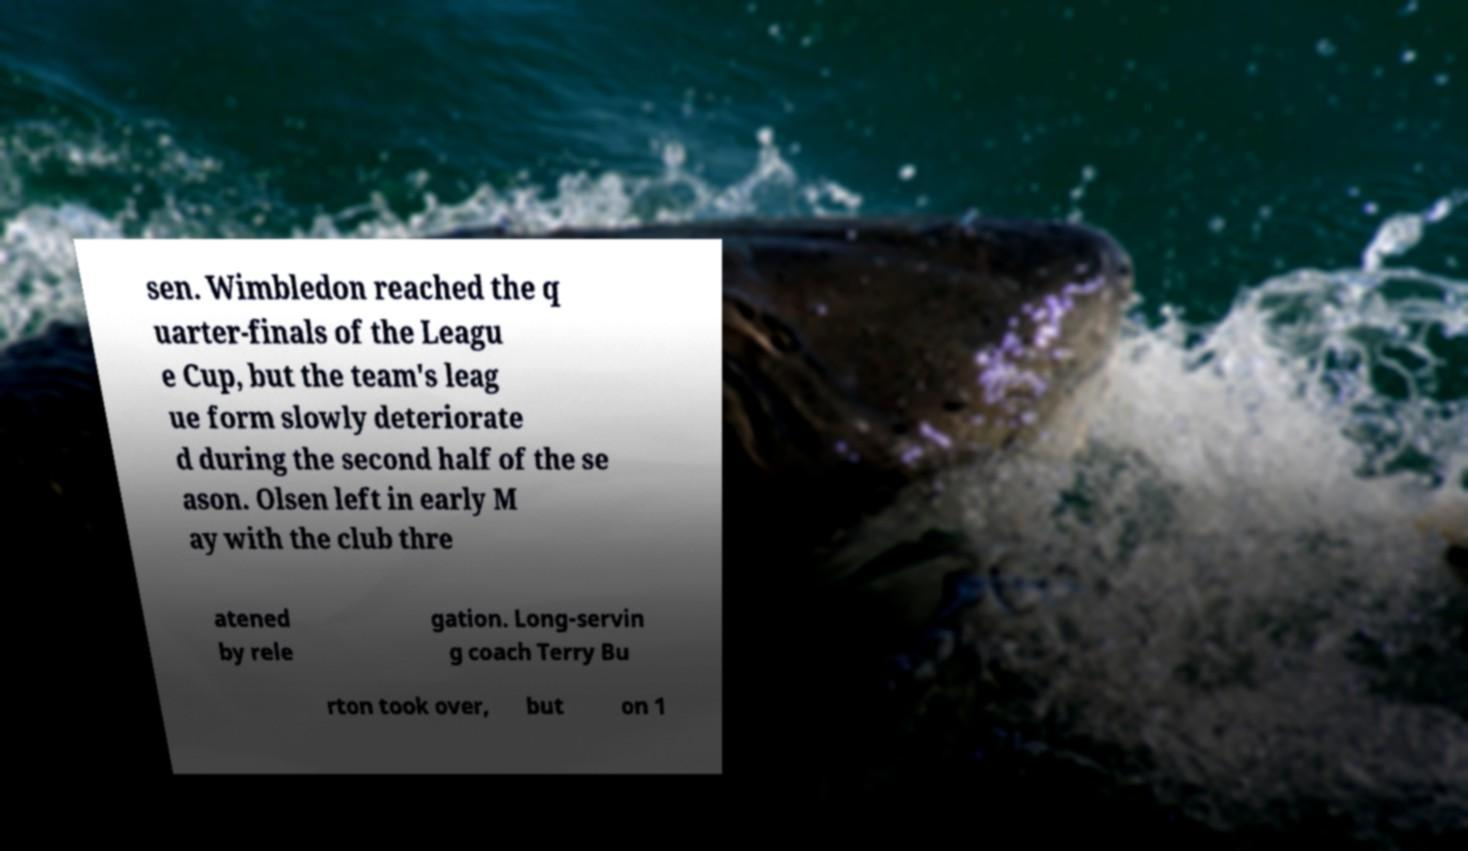Please identify and transcribe the text found in this image. sen. Wimbledon reached the q uarter-finals of the Leagu e Cup, but the team's leag ue form slowly deteriorate d during the second half of the se ason. Olsen left in early M ay with the club thre atened by rele gation. Long-servin g coach Terry Bu rton took over, but on 1 